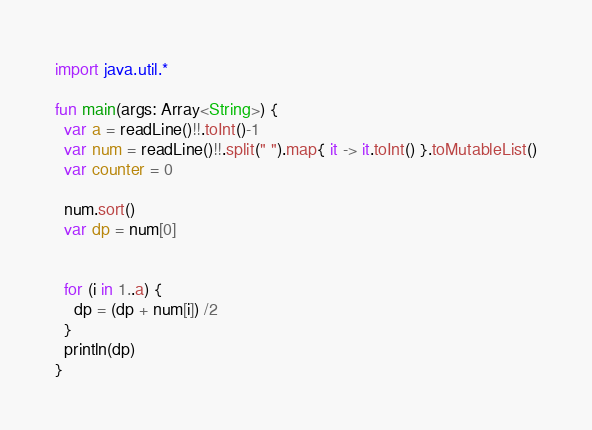Convert code to text. <code><loc_0><loc_0><loc_500><loc_500><_Kotlin_>import java.util.*
 
fun main(args: Array<String>) {
  var a = readLine()!!.toInt()-1
  var num = readLine()!!.split(" ").map{ it -> it.toInt() }.toMutableList()
  var counter = 0
  
  num.sort()
  var dp = num[0]

  
  for (i in 1..a) {
    dp = (dp + num[i]) /2
  }
  println(dp)
}</code> 